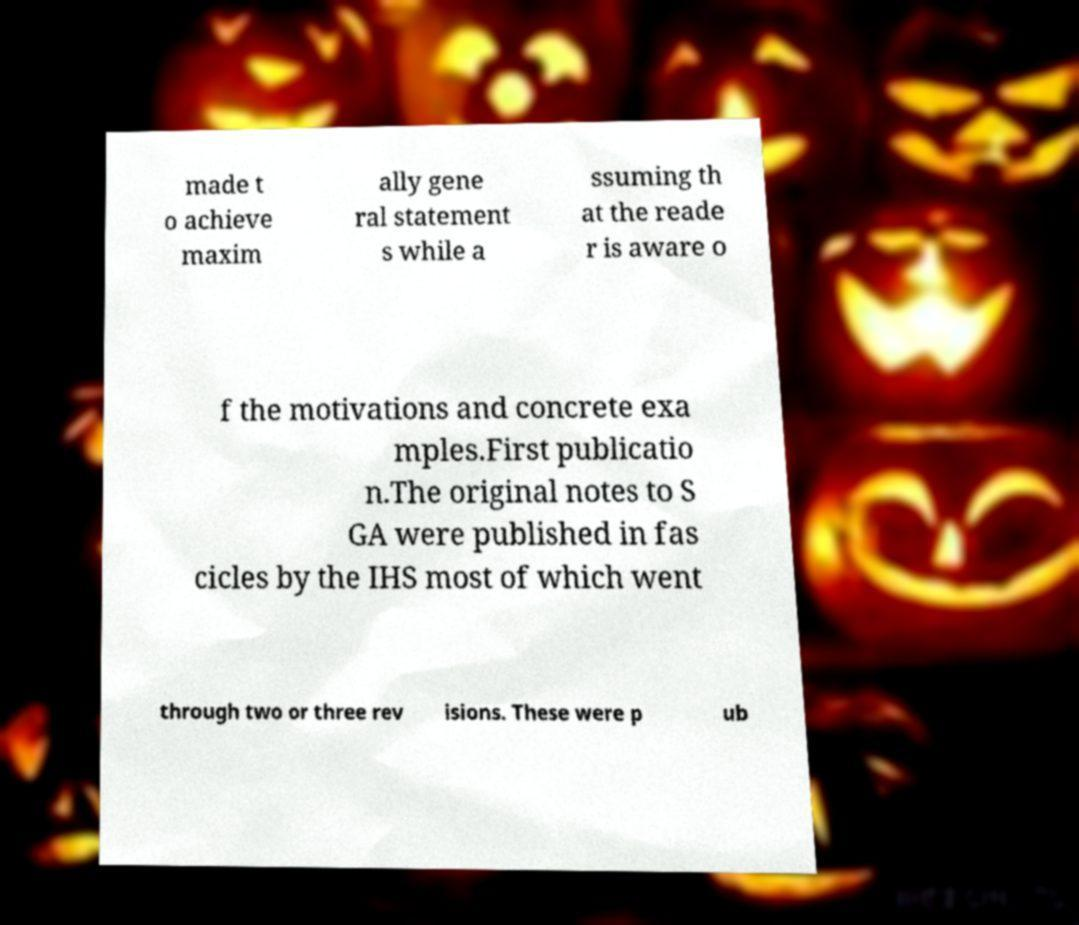I need the written content from this picture converted into text. Can you do that? made t o achieve maxim ally gene ral statement s while a ssuming th at the reade r is aware o f the motivations and concrete exa mples.First publicatio n.The original notes to S GA were published in fas cicles by the IHS most of which went through two or three rev isions. These were p ub 